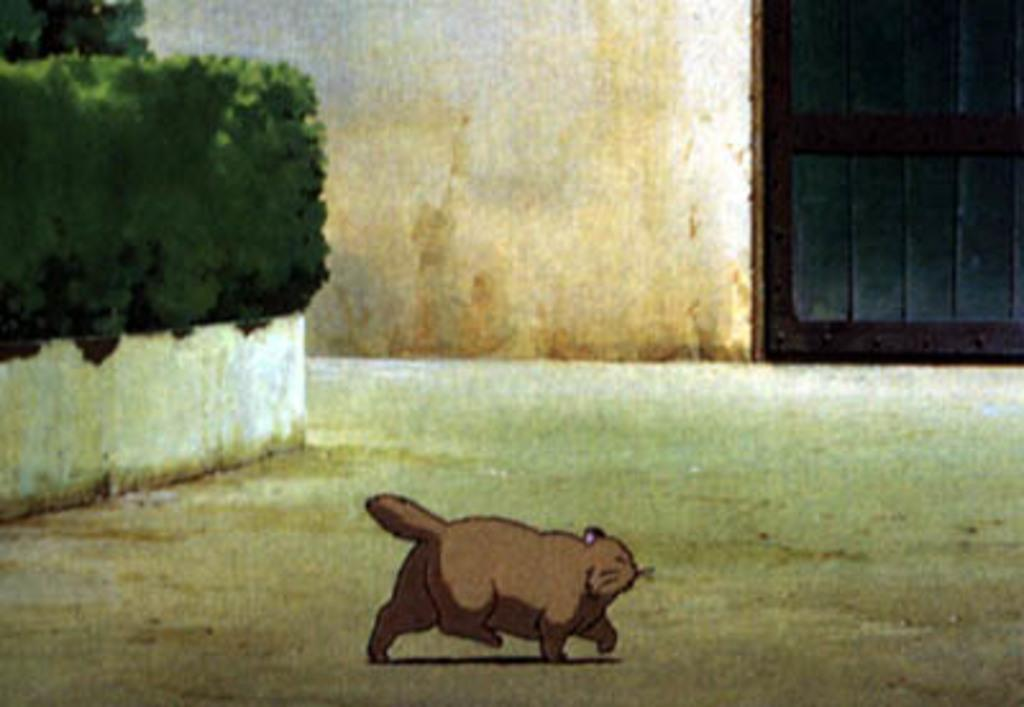What type of image is depicted in the picture? There is a cartoon in the image. What can be seen in the background of the cartoon? There is a door, a wall, and plants in the background of the image. What is visible at the bottom of the image? There is ground visible at the bottom of the image. What type of chin can be seen on the cartoon character in the image? There is no chin visible on the cartoon character in the image, as cartoons typically do not have realistic human features. 